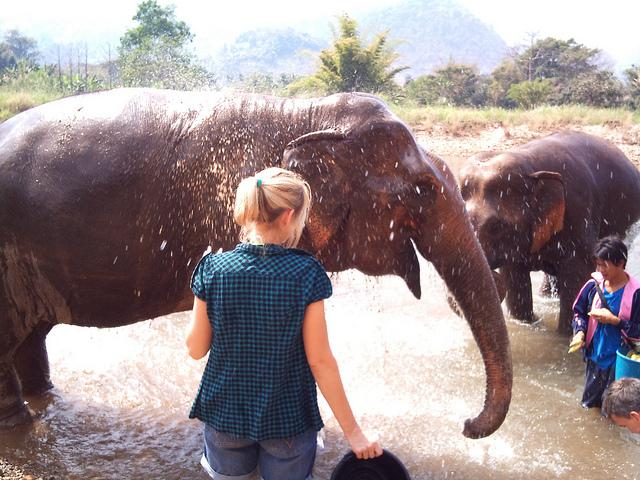Which part of the Elephant's body work to cool their body? trunk 